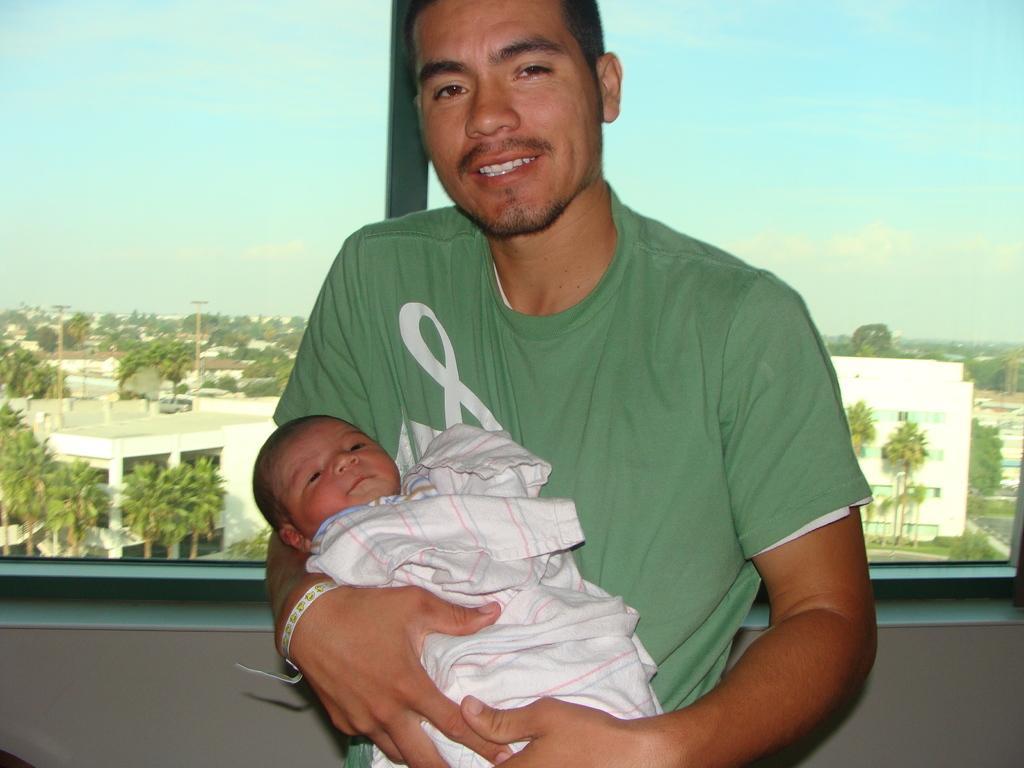How would you summarize this image in a sentence or two? There is a man holding a kid with his hands and he is smiling. There is a glass window. From the glass we can see trees, buildings, poles, and sky. 